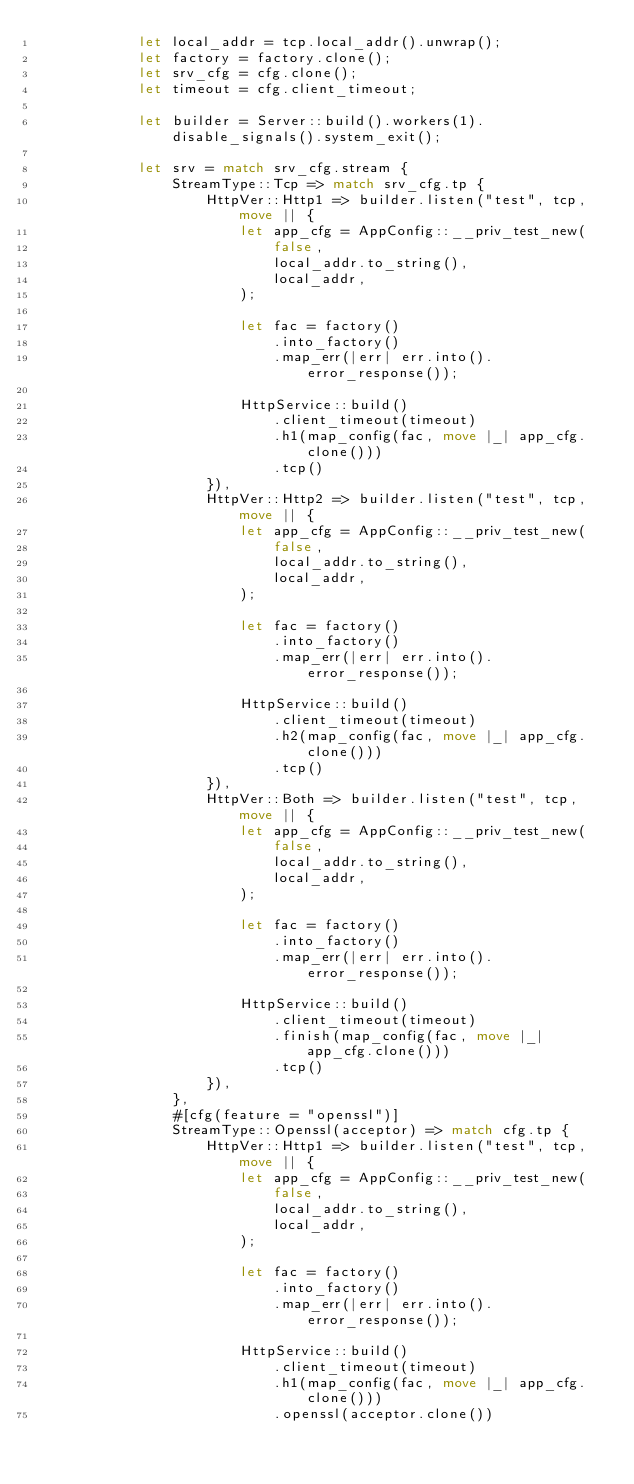Convert code to text. <code><loc_0><loc_0><loc_500><loc_500><_Rust_>            let local_addr = tcp.local_addr().unwrap();
            let factory = factory.clone();
            let srv_cfg = cfg.clone();
            let timeout = cfg.client_timeout;

            let builder = Server::build().workers(1).disable_signals().system_exit();

            let srv = match srv_cfg.stream {
                StreamType::Tcp => match srv_cfg.tp {
                    HttpVer::Http1 => builder.listen("test", tcp, move || {
                        let app_cfg = AppConfig::__priv_test_new(
                            false,
                            local_addr.to_string(),
                            local_addr,
                        );

                        let fac = factory()
                            .into_factory()
                            .map_err(|err| err.into().error_response());

                        HttpService::build()
                            .client_timeout(timeout)
                            .h1(map_config(fac, move |_| app_cfg.clone()))
                            .tcp()
                    }),
                    HttpVer::Http2 => builder.listen("test", tcp, move || {
                        let app_cfg = AppConfig::__priv_test_new(
                            false,
                            local_addr.to_string(),
                            local_addr,
                        );

                        let fac = factory()
                            .into_factory()
                            .map_err(|err| err.into().error_response());

                        HttpService::build()
                            .client_timeout(timeout)
                            .h2(map_config(fac, move |_| app_cfg.clone()))
                            .tcp()
                    }),
                    HttpVer::Both => builder.listen("test", tcp, move || {
                        let app_cfg = AppConfig::__priv_test_new(
                            false,
                            local_addr.to_string(),
                            local_addr,
                        );

                        let fac = factory()
                            .into_factory()
                            .map_err(|err| err.into().error_response());

                        HttpService::build()
                            .client_timeout(timeout)
                            .finish(map_config(fac, move |_| app_cfg.clone()))
                            .tcp()
                    }),
                },
                #[cfg(feature = "openssl")]
                StreamType::Openssl(acceptor) => match cfg.tp {
                    HttpVer::Http1 => builder.listen("test", tcp, move || {
                        let app_cfg = AppConfig::__priv_test_new(
                            false,
                            local_addr.to_string(),
                            local_addr,
                        );

                        let fac = factory()
                            .into_factory()
                            .map_err(|err| err.into().error_response());

                        HttpService::build()
                            .client_timeout(timeout)
                            .h1(map_config(fac, move |_| app_cfg.clone()))
                            .openssl(acceptor.clone())</code> 